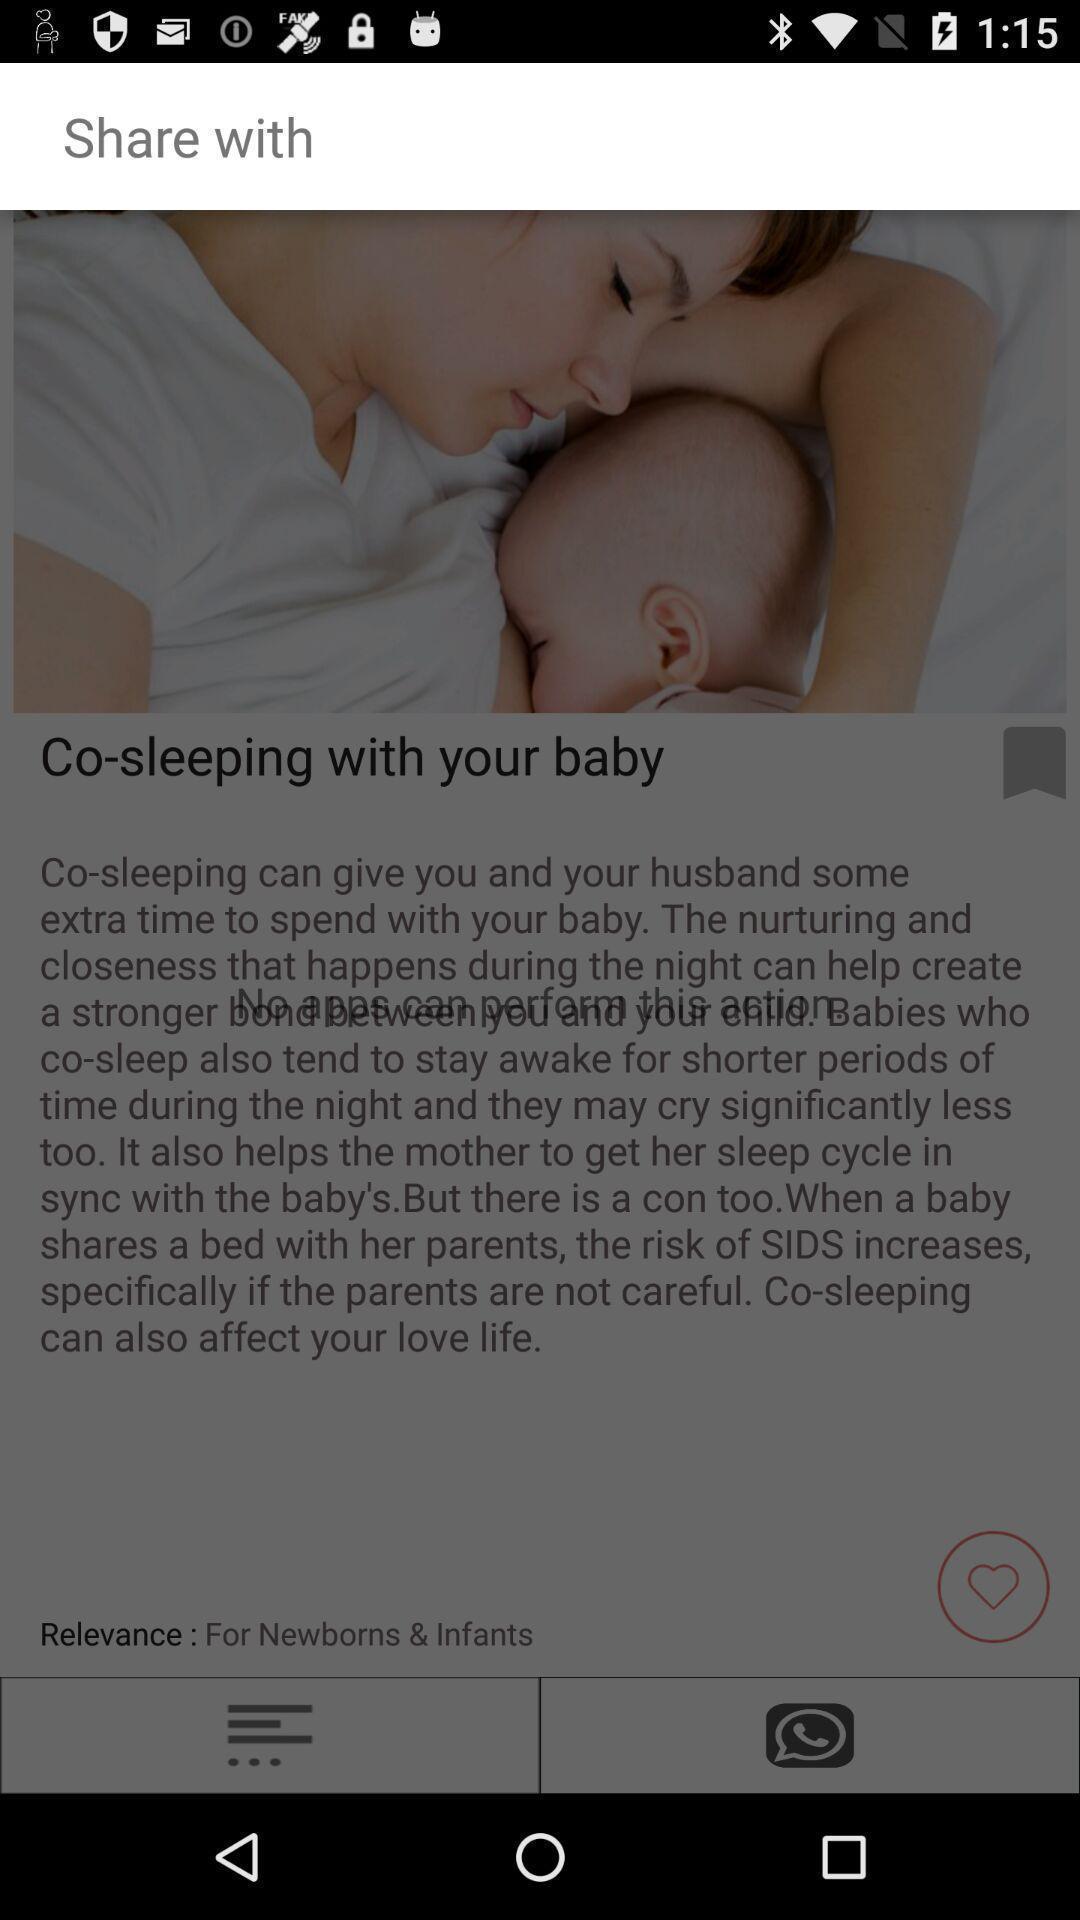Describe this image in words. Share page of baby care news. 